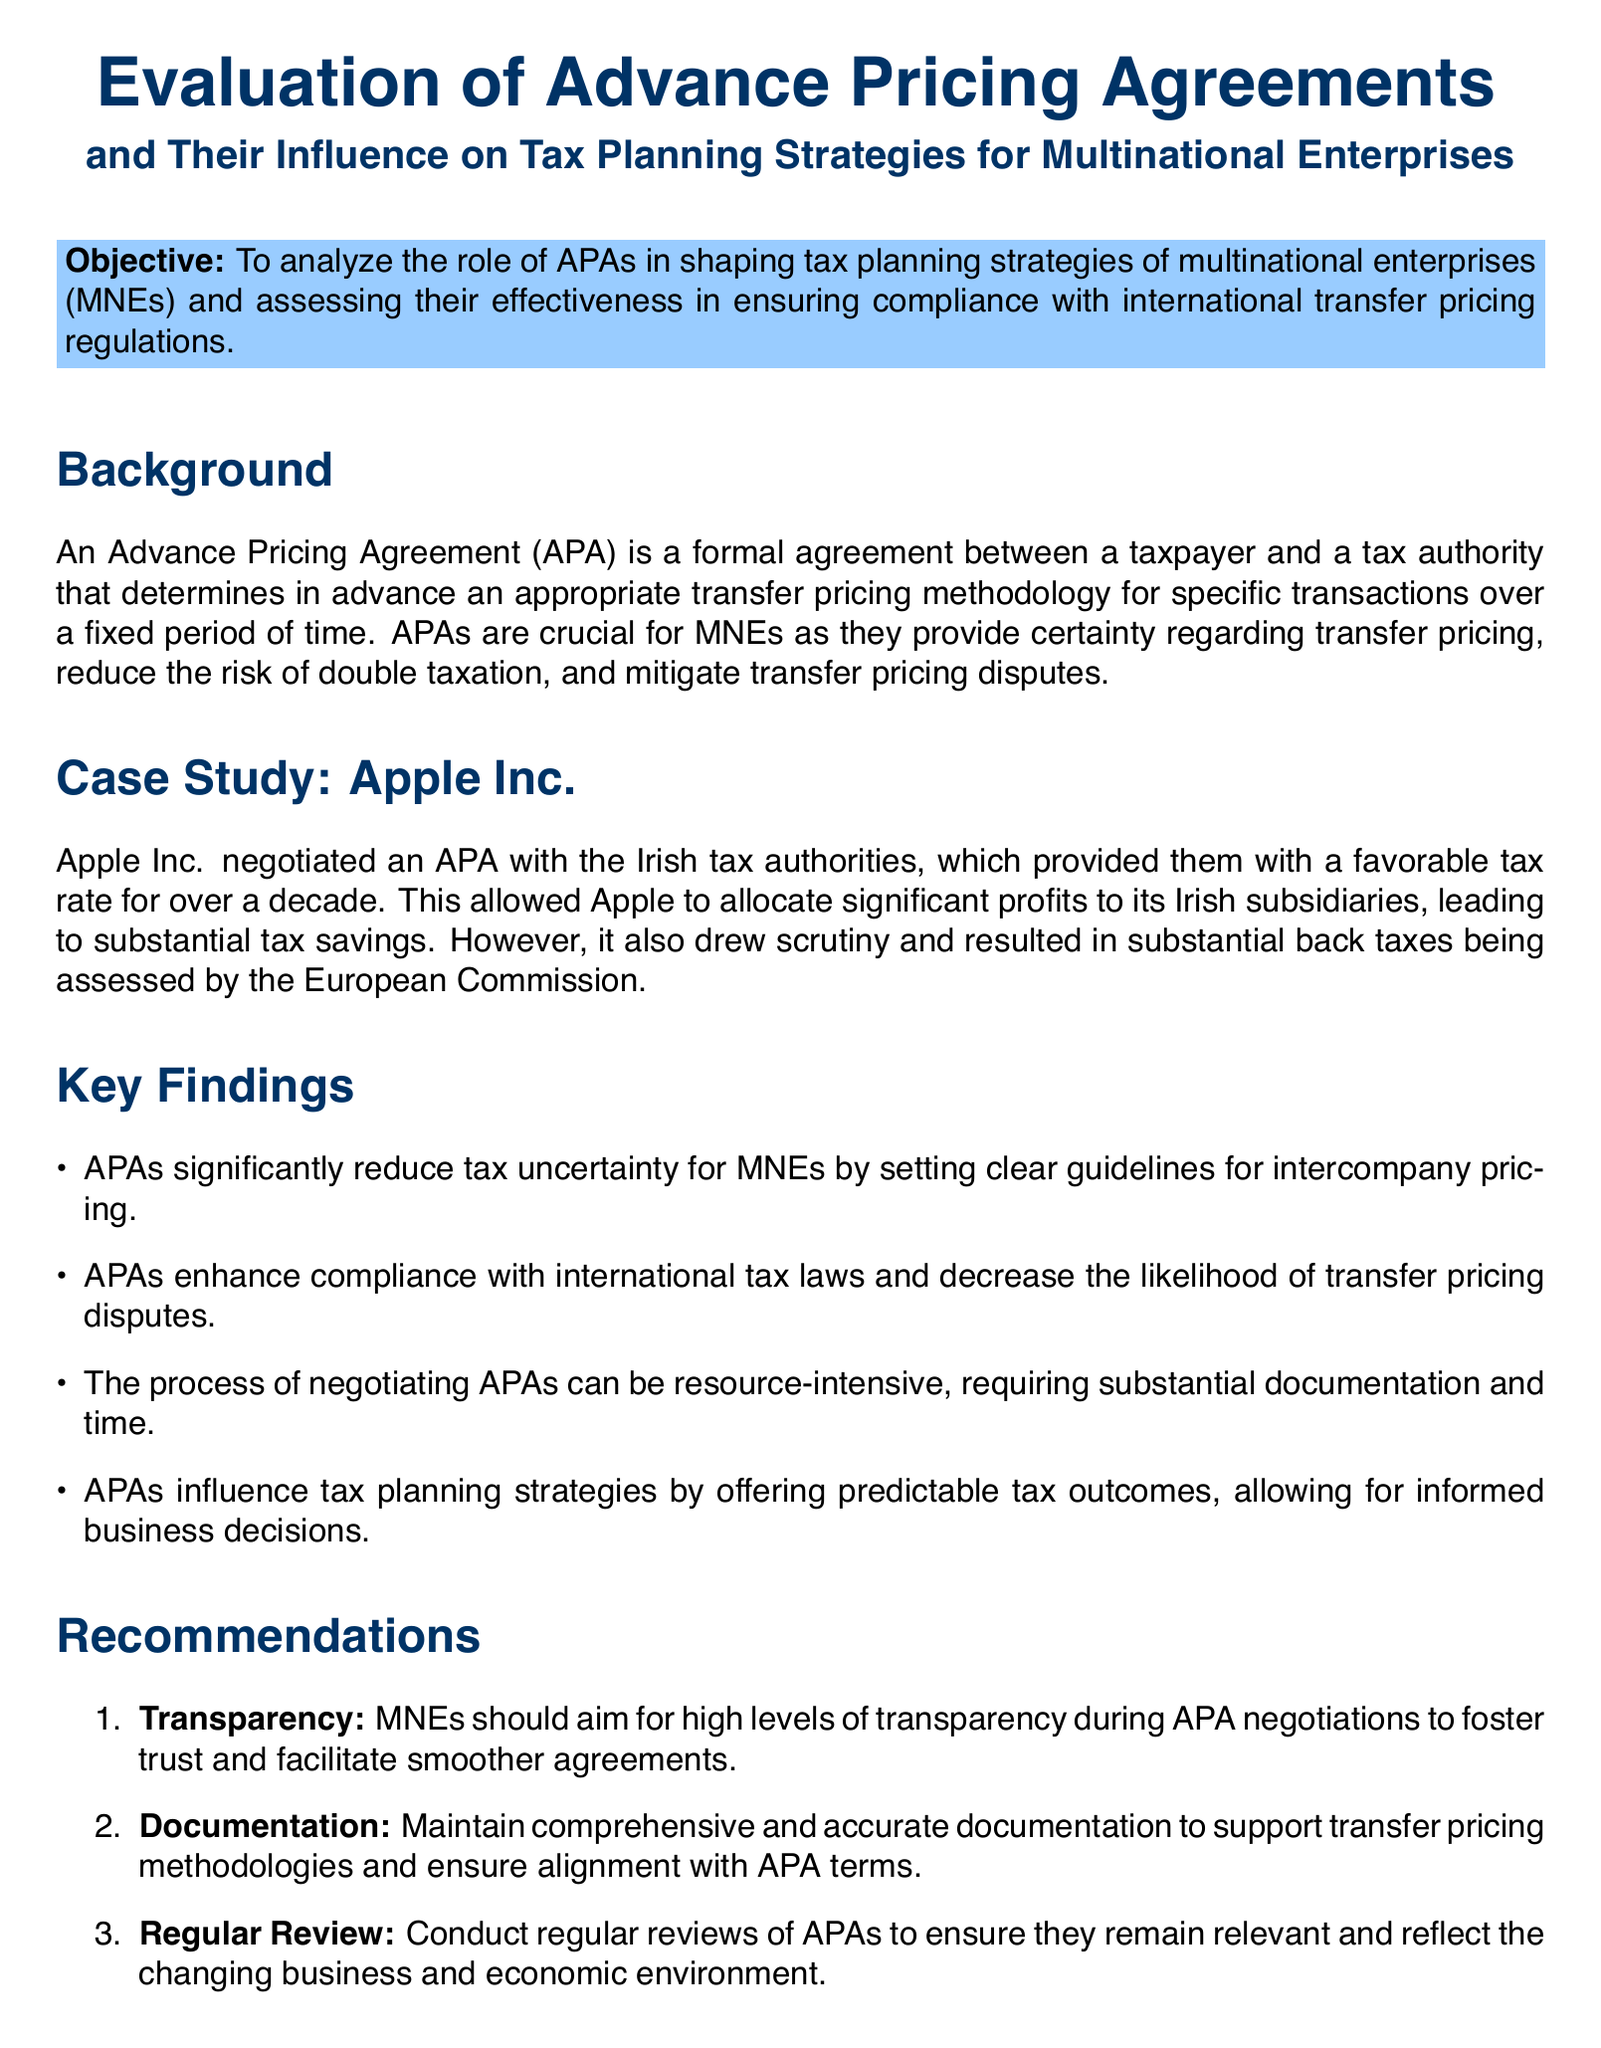What is the main objective of the study? The objective is stated in the document as the purpose of analyzing the role of APAs in shaping tax planning strategies and ensuring compliance.
Answer: To analyze the role of APAs in shaping tax planning strategies of MNEs and assessing their effectiveness in ensuring compliance with international transfer pricing regulations What company is used as a case study in the report? The document clearly states that Apple Inc. is presented as a case study to illustrate the impact of APAs.
Answer: Apple Inc What is one key finding regarding APAs? The document lists several key findings, one of which highlights the impact of APAs on tax uncertainty.
Answer: APAs significantly reduce tax uncertainty for MNEs What is recommended for MNEs during APA negotiations? The report makes recommendations, including the need for transparency during APA negotiations.
Answer: Transparency How long did Apple benefit from its negotiated APA? The document mentions that Apple had a favorable tax rate for over a decade, indicating the duration of the benefit.
Answer: Over a decade What should MNEs maintain to support transfer pricing methodologies? The recommendations section advises maintaining comprehensive and accurate documentation.
Answer: Comprehensive and accurate documentation What is the nature of the process for negotiating APAs? A key finding in the document describes the negotiation process as requiring substantial resources.
Answer: Resource-intensive What do APAs help enhance according to the findings? The findings mention a specific outcome that APAs help achieve regarding tax laws.
Answer: Compliance with international tax laws 